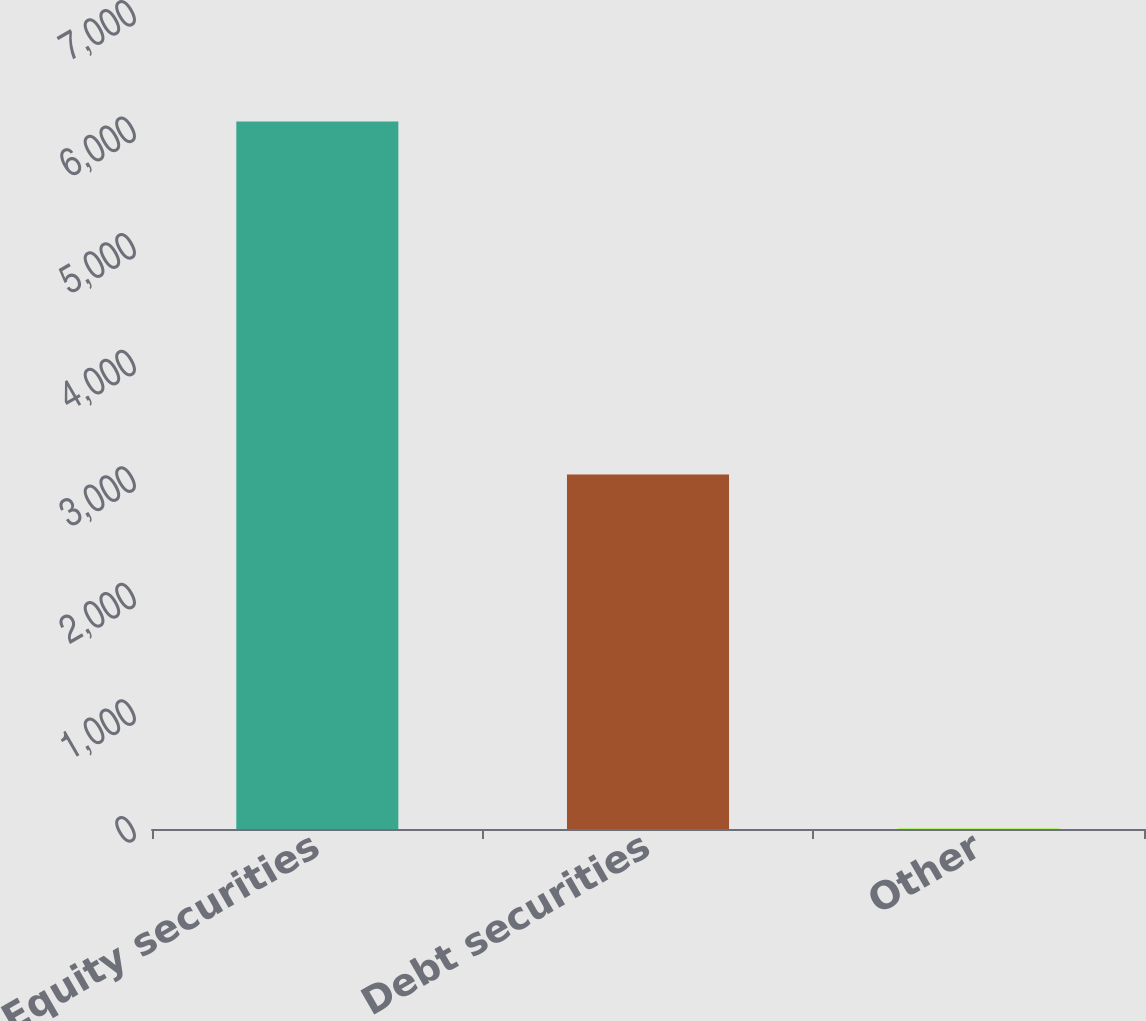<chart> <loc_0><loc_0><loc_500><loc_500><bar_chart><fcel>Equity securities<fcel>Debt securities<fcel>Other<nl><fcel>6070<fcel>3040<fcel>5<nl></chart> 